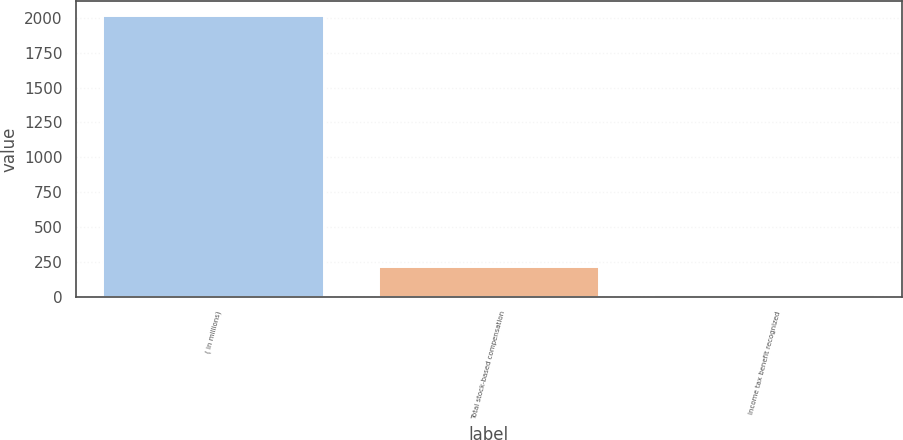<chart> <loc_0><loc_0><loc_500><loc_500><bar_chart><fcel>( in millions)<fcel>Total stock-based compensation<fcel>Income tax benefit recognized<nl><fcel>2015<fcel>217.7<fcel>18<nl></chart> 